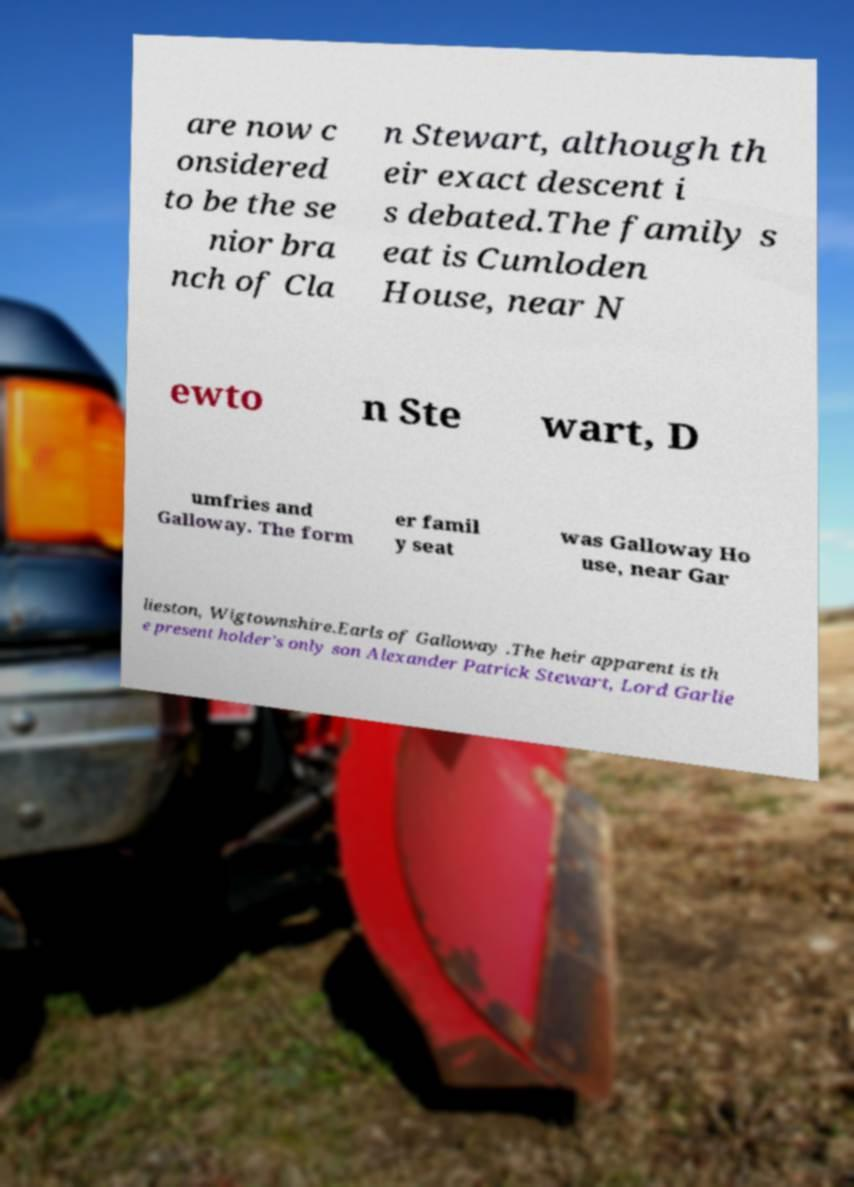Could you extract and type out the text from this image? are now c onsidered to be the se nior bra nch of Cla n Stewart, although th eir exact descent i s debated.The family s eat is Cumloden House, near N ewto n Ste wart, D umfries and Galloway. The form er famil y seat was Galloway Ho use, near Gar lieston, Wigtownshire.Earls of Galloway .The heir apparent is th e present holder's only son Alexander Patrick Stewart, Lord Garlie 